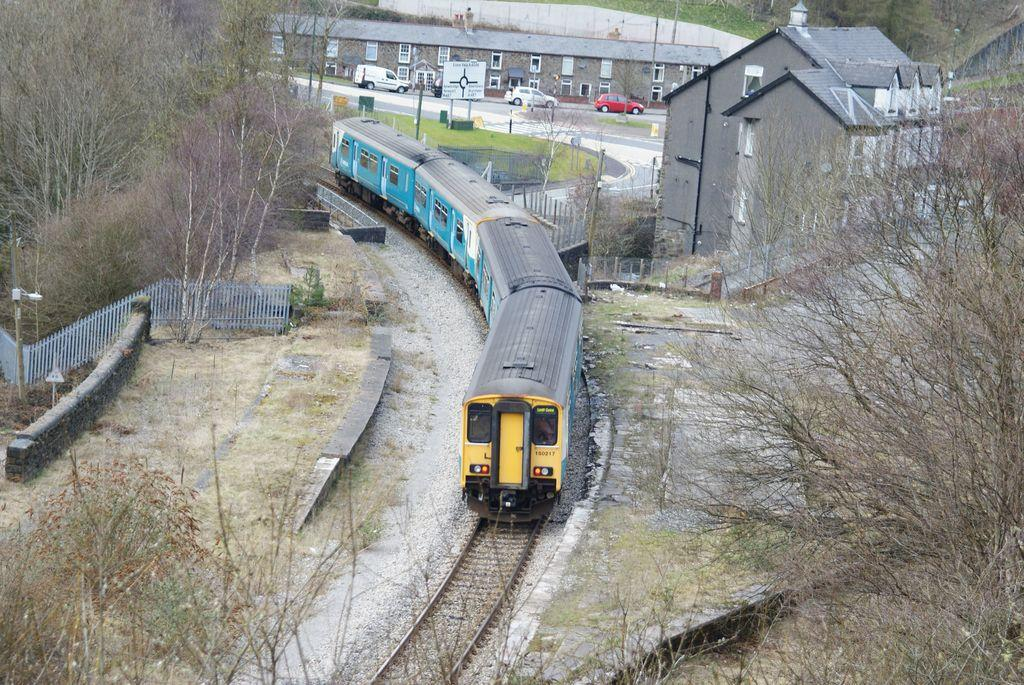What is the main subject of the image? The main subject of the image is a train on the track. What type of vegetation can be seen in the image? There are trees and plants in the image. What type of barrier is present in the image? There is fencing in the image. What type of vehicles are visible in the image? There are cars in the image. What type of structures can be seen in the image? There are buildings in the image. What is the cause of the camp in the image? There is no camp present in the image, so it is not possible to determine the cause. 